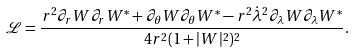Convert formula to latex. <formula><loc_0><loc_0><loc_500><loc_500>\mathcal { L } = \frac { r ^ { 2 } \partial _ { r } W \partial _ { r } W ^ { * } + \partial _ { \theta } W \partial _ { \theta } W ^ { * } - r ^ { 2 } \dot { \lambda } ^ { 2 } \partial _ { \lambda } W \partial _ { \lambda } W ^ { * } } { 4 r ^ { 2 } ( 1 + | W | ^ { 2 } ) ^ { 2 } } .</formula> 